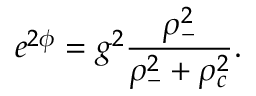Convert formula to latex. <formula><loc_0><loc_0><loc_500><loc_500>e ^ { 2 \phi } = g ^ { 2 } \frac { \rho _ { - } ^ { 2 } } { \rho _ { - } ^ { 2 } + \rho _ { c } ^ { 2 } } .</formula> 